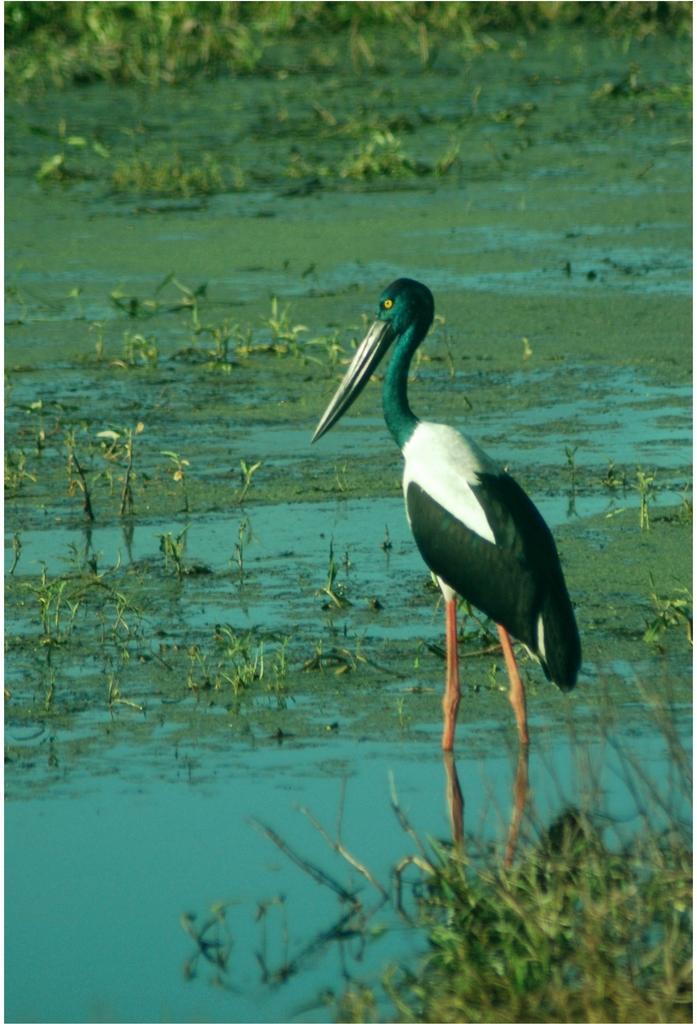Please provide a concise description of this image. This image is taken outdoors. At the bottom of the image there is a pond with water and grass. On the right side of the image there is a crane. 